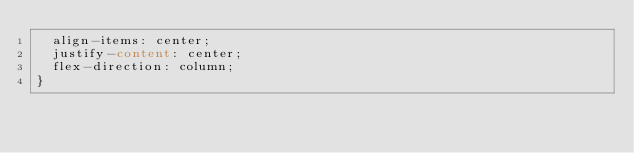<code> <loc_0><loc_0><loc_500><loc_500><_CSS_>  align-items: center;
  justify-content: center;
  flex-direction: column;
}
</code> 